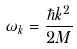<formula> <loc_0><loc_0><loc_500><loc_500>\omega _ { k } = \frac { \hbar { k } ^ { 2 } } { 2 M }</formula> 